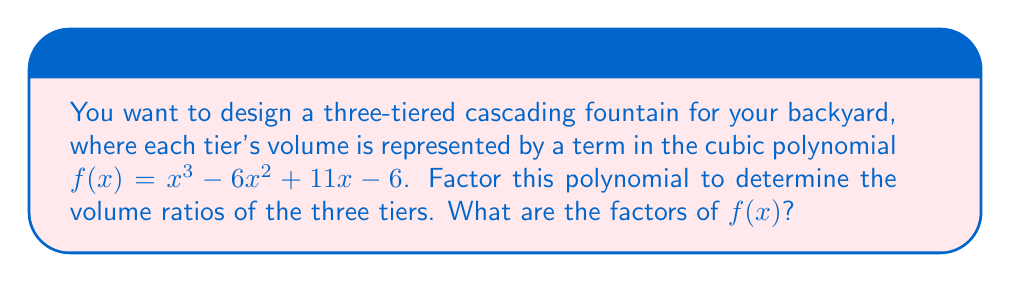Can you solve this math problem? To factor the cubic polynomial $f(x) = x^3 - 6x^2 + 11x - 6$, we'll follow these steps:

1) First, let's check if there's a rational root using the rational root theorem. The possible rational roots are the factors of the constant term: ±1, ±2, ±3, ±6.

2) Testing these values, we find that $f(1) = 0$. So $(x-1)$ is a factor.

3) We can use polynomial long division to divide $f(x)$ by $(x-1)$:

   $$x^3 - 6x^2 + 11x - 6 = (x-1)(x^2 - 5x + 6)$$

4) Now we need to factor the quadratic term $x^2 - 5x + 6$. We can do this by finding two numbers that multiply to give 6 and add to give -5. These numbers are -2 and -3.

5) Therefore, $x^2 - 5x + 6 = (x-2)(x-3)$

6) Combining all factors, we get:

   $$f(x) = (x-1)(x-2)(x-3)$$

This factorization represents the volume ratios of your three-tiered fountain. Each factor $(x-1)$, $(x-2)$, and $(x-3)$ corresponds to a tier of the fountain.
Answer: $(x-1)(x-2)(x-3)$ 